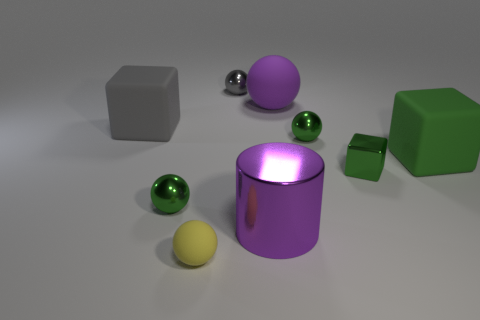Add 1 big purple rubber spheres. How many objects exist? 10 Subtract all yellow balls. How many balls are left? 4 Subtract all gray shiny balls. How many balls are left? 4 Subtract all spheres. How many objects are left? 4 Subtract all blue balls. Subtract all cyan cylinders. How many balls are left? 5 Subtract 1 gray spheres. How many objects are left? 8 Subtract all gray metallic objects. Subtract all large purple rubber spheres. How many objects are left? 7 Add 4 large purple balls. How many large purple balls are left? 5 Add 5 large things. How many large things exist? 9 